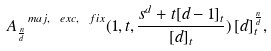<formula> <loc_0><loc_0><loc_500><loc_500>A ^ { \ m a j , \ e x c , \ f i x } _ { \frac { n } { d } } ( 1 , t , \frac { s ^ { d } + t [ d - 1 ] _ { t } } { [ d ] _ { t } } ) \, [ d ] _ { t } ^ { \frac { n } { d } } ,</formula> 